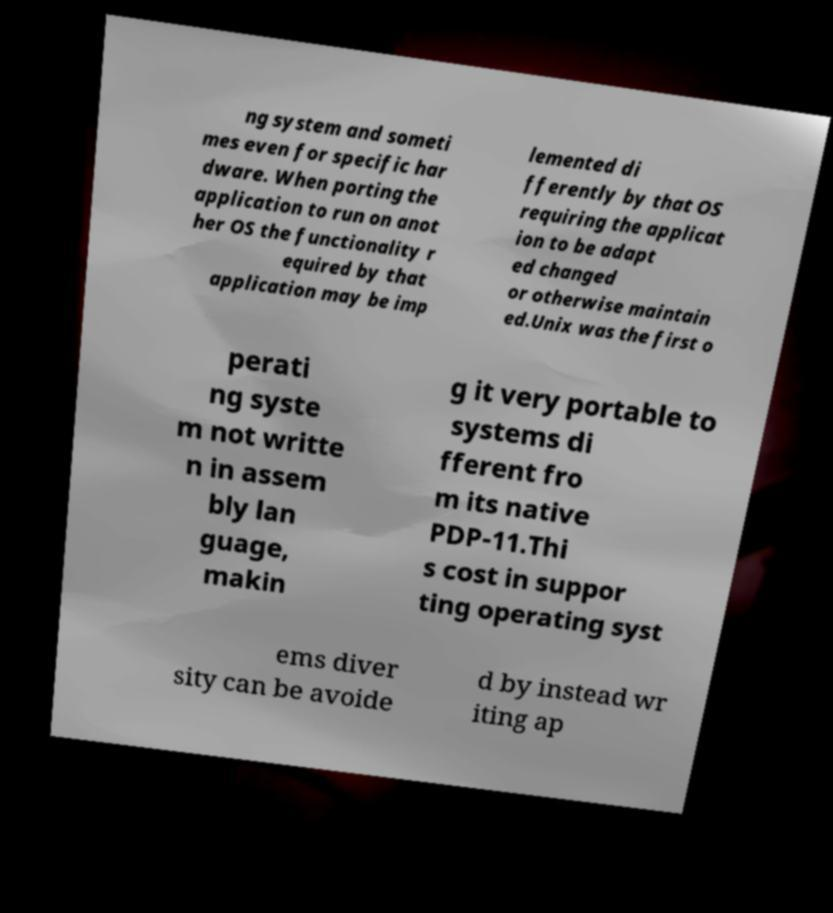Could you extract and type out the text from this image? ng system and someti mes even for specific har dware. When porting the application to run on anot her OS the functionality r equired by that application may be imp lemented di fferently by that OS requiring the applicat ion to be adapt ed changed or otherwise maintain ed.Unix was the first o perati ng syste m not writte n in assem bly lan guage, makin g it very portable to systems di fferent fro m its native PDP-11.Thi s cost in suppor ting operating syst ems diver sity can be avoide d by instead wr iting ap 